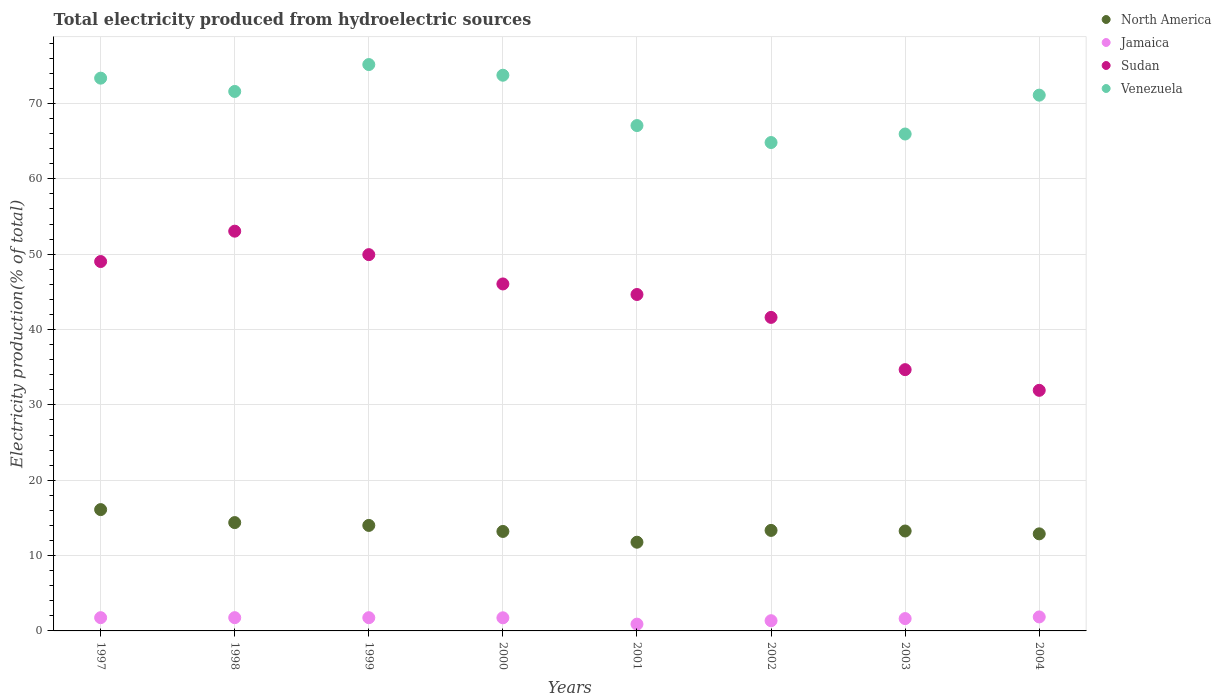Is the number of dotlines equal to the number of legend labels?
Ensure brevity in your answer.  Yes. What is the total electricity produced in Sudan in 1997?
Offer a terse response. 49.02. Across all years, what is the maximum total electricity produced in Sudan?
Offer a terse response. 53.05. Across all years, what is the minimum total electricity produced in Venezuela?
Your answer should be very brief. 64.82. In which year was the total electricity produced in Jamaica maximum?
Make the answer very short. 2004. What is the total total electricity produced in North America in the graph?
Offer a terse response. 108.94. What is the difference between the total electricity produced in North America in 1997 and that in 2004?
Give a very brief answer. 3.22. What is the difference between the total electricity produced in Venezuela in 2004 and the total electricity produced in North America in 1999?
Your response must be concise. 57.1. What is the average total electricity produced in Sudan per year?
Provide a succinct answer. 43.87. In the year 1997, what is the difference between the total electricity produced in North America and total electricity produced in Venezuela?
Your answer should be compact. -57.26. What is the ratio of the total electricity produced in Venezuela in 2000 to that in 2001?
Your answer should be very brief. 1.1. Is the difference between the total electricity produced in North America in 2003 and 2004 greater than the difference between the total electricity produced in Venezuela in 2003 and 2004?
Your response must be concise. Yes. What is the difference between the highest and the second highest total electricity produced in Venezuela?
Offer a terse response. 1.42. What is the difference between the highest and the lowest total electricity produced in Jamaica?
Offer a terse response. 0.96. Is it the case that in every year, the sum of the total electricity produced in Sudan and total electricity produced in Jamaica  is greater than the sum of total electricity produced in North America and total electricity produced in Venezuela?
Give a very brief answer. No. Is it the case that in every year, the sum of the total electricity produced in Jamaica and total electricity produced in Sudan  is greater than the total electricity produced in North America?
Provide a succinct answer. Yes. Does the total electricity produced in Jamaica monotonically increase over the years?
Provide a succinct answer. No. Is the total electricity produced in Jamaica strictly less than the total electricity produced in Venezuela over the years?
Provide a short and direct response. Yes. Are the values on the major ticks of Y-axis written in scientific E-notation?
Make the answer very short. No. Does the graph contain grids?
Provide a short and direct response. Yes. Where does the legend appear in the graph?
Keep it short and to the point. Top right. What is the title of the graph?
Your answer should be compact. Total electricity produced from hydroelectric sources. What is the label or title of the X-axis?
Give a very brief answer. Years. What is the Electricity production(% of total) in North America in 1997?
Make the answer very short. 16.1. What is the Electricity production(% of total) in Jamaica in 1997?
Ensure brevity in your answer.  1.76. What is the Electricity production(% of total) in Sudan in 1997?
Offer a terse response. 49.02. What is the Electricity production(% of total) in Venezuela in 1997?
Your response must be concise. 73.36. What is the Electricity production(% of total) of North America in 1998?
Offer a terse response. 14.38. What is the Electricity production(% of total) of Jamaica in 1998?
Keep it short and to the point. 1.76. What is the Electricity production(% of total) of Sudan in 1998?
Ensure brevity in your answer.  53.05. What is the Electricity production(% of total) in Venezuela in 1998?
Provide a succinct answer. 71.6. What is the Electricity production(% of total) of North America in 1999?
Give a very brief answer. 14. What is the Electricity production(% of total) of Jamaica in 1999?
Offer a terse response. 1.76. What is the Electricity production(% of total) of Sudan in 1999?
Make the answer very short. 49.94. What is the Electricity production(% of total) of Venezuela in 1999?
Keep it short and to the point. 75.16. What is the Electricity production(% of total) of North America in 2000?
Offer a very short reply. 13.2. What is the Electricity production(% of total) in Jamaica in 2000?
Provide a short and direct response. 1.74. What is the Electricity production(% of total) of Sudan in 2000?
Offer a terse response. 46.05. What is the Electricity production(% of total) of Venezuela in 2000?
Offer a very short reply. 73.75. What is the Electricity production(% of total) in North America in 2001?
Keep it short and to the point. 11.77. What is the Electricity production(% of total) in Jamaica in 2001?
Provide a succinct answer. 0.9. What is the Electricity production(% of total) of Sudan in 2001?
Offer a terse response. 44.65. What is the Electricity production(% of total) in Venezuela in 2001?
Your answer should be very brief. 67.07. What is the Electricity production(% of total) of North America in 2002?
Give a very brief answer. 13.34. What is the Electricity production(% of total) of Jamaica in 2002?
Your answer should be very brief. 1.36. What is the Electricity production(% of total) in Sudan in 2002?
Keep it short and to the point. 41.61. What is the Electricity production(% of total) in Venezuela in 2002?
Ensure brevity in your answer.  64.82. What is the Electricity production(% of total) in North America in 2003?
Provide a short and direct response. 13.26. What is the Electricity production(% of total) of Jamaica in 2003?
Make the answer very short. 1.64. What is the Electricity production(% of total) in Sudan in 2003?
Provide a succinct answer. 34.68. What is the Electricity production(% of total) in Venezuela in 2003?
Provide a short and direct response. 65.95. What is the Electricity production(% of total) in North America in 2004?
Your answer should be very brief. 12.88. What is the Electricity production(% of total) of Jamaica in 2004?
Make the answer very short. 1.86. What is the Electricity production(% of total) in Sudan in 2004?
Offer a very short reply. 31.93. What is the Electricity production(% of total) in Venezuela in 2004?
Your response must be concise. 71.1. Across all years, what is the maximum Electricity production(% of total) of North America?
Provide a short and direct response. 16.1. Across all years, what is the maximum Electricity production(% of total) of Jamaica?
Make the answer very short. 1.86. Across all years, what is the maximum Electricity production(% of total) in Sudan?
Provide a short and direct response. 53.05. Across all years, what is the maximum Electricity production(% of total) in Venezuela?
Ensure brevity in your answer.  75.16. Across all years, what is the minimum Electricity production(% of total) of North America?
Give a very brief answer. 11.77. Across all years, what is the minimum Electricity production(% of total) in Jamaica?
Provide a succinct answer. 0.9. Across all years, what is the minimum Electricity production(% of total) in Sudan?
Your answer should be compact. 31.93. Across all years, what is the minimum Electricity production(% of total) in Venezuela?
Offer a very short reply. 64.82. What is the total Electricity production(% of total) in North America in the graph?
Provide a succinct answer. 108.94. What is the total Electricity production(% of total) in Jamaica in the graph?
Give a very brief answer. 12.77. What is the total Electricity production(% of total) of Sudan in the graph?
Your response must be concise. 350.92. What is the total Electricity production(% of total) in Venezuela in the graph?
Keep it short and to the point. 562.8. What is the difference between the Electricity production(% of total) in North America in 1997 and that in 1998?
Your answer should be very brief. 1.72. What is the difference between the Electricity production(% of total) in Jamaica in 1997 and that in 1998?
Ensure brevity in your answer.  -0. What is the difference between the Electricity production(% of total) in Sudan in 1997 and that in 1998?
Give a very brief answer. -4.03. What is the difference between the Electricity production(% of total) of Venezuela in 1997 and that in 1998?
Offer a very short reply. 1.76. What is the difference between the Electricity production(% of total) in North America in 1997 and that in 1999?
Keep it short and to the point. 2.1. What is the difference between the Electricity production(% of total) of Jamaica in 1997 and that in 1999?
Offer a terse response. 0. What is the difference between the Electricity production(% of total) of Sudan in 1997 and that in 1999?
Provide a succinct answer. -0.91. What is the difference between the Electricity production(% of total) of Venezuela in 1997 and that in 1999?
Offer a terse response. -1.81. What is the difference between the Electricity production(% of total) in North America in 1997 and that in 2000?
Your answer should be very brief. 2.9. What is the difference between the Electricity production(% of total) in Jamaica in 1997 and that in 2000?
Provide a succinct answer. 0.02. What is the difference between the Electricity production(% of total) of Sudan in 1997 and that in 2000?
Make the answer very short. 2.97. What is the difference between the Electricity production(% of total) in Venezuela in 1997 and that in 2000?
Make the answer very short. -0.39. What is the difference between the Electricity production(% of total) of North America in 1997 and that in 2001?
Provide a short and direct response. 4.33. What is the difference between the Electricity production(% of total) in Jamaica in 1997 and that in 2001?
Keep it short and to the point. 0.86. What is the difference between the Electricity production(% of total) in Sudan in 1997 and that in 2001?
Give a very brief answer. 4.38. What is the difference between the Electricity production(% of total) of Venezuela in 1997 and that in 2001?
Give a very brief answer. 6.29. What is the difference between the Electricity production(% of total) of North America in 1997 and that in 2002?
Offer a very short reply. 2.76. What is the difference between the Electricity production(% of total) in Jamaica in 1997 and that in 2002?
Provide a short and direct response. 0.4. What is the difference between the Electricity production(% of total) in Sudan in 1997 and that in 2002?
Give a very brief answer. 7.41. What is the difference between the Electricity production(% of total) in Venezuela in 1997 and that in 2002?
Your response must be concise. 8.54. What is the difference between the Electricity production(% of total) of North America in 1997 and that in 2003?
Ensure brevity in your answer.  2.84. What is the difference between the Electricity production(% of total) of Jamaica in 1997 and that in 2003?
Give a very brief answer. 0.12. What is the difference between the Electricity production(% of total) of Sudan in 1997 and that in 2003?
Your response must be concise. 14.35. What is the difference between the Electricity production(% of total) of Venezuela in 1997 and that in 2003?
Make the answer very short. 7.41. What is the difference between the Electricity production(% of total) in North America in 1997 and that in 2004?
Provide a succinct answer. 3.22. What is the difference between the Electricity production(% of total) of Jamaica in 1997 and that in 2004?
Your response must be concise. -0.1. What is the difference between the Electricity production(% of total) of Sudan in 1997 and that in 2004?
Keep it short and to the point. 17.09. What is the difference between the Electricity production(% of total) of Venezuela in 1997 and that in 2004?
Your answer should be very brief. 2.25. What is the difference between the Electricity production(% of total) of North America in 1998 and that in 1999?
Keep it short and to the point. 0.38. What is the difference between the Electricity production(% of total) in Jamaica in 1998 and that in 1999?
Offer a very short reply. 0. What is the difference between the Electricity production(% of total) in Sudan in 1998 and that in 1999?
Ensure brevity in your answer.  3.11. What is the difference between the Electricity production(% of total) in Venezuela in 1998 and that in 1999?
Your answer should be compact. -3.57. What is the difference between the Electricity production(% of total) of North America in 1998 and that in 2000?
Keep it short and to the point. 1.17. What is the difference between the Electricity production(% of total) in Jamaica in 1998 and that in 2000?
Your response must be concise. 0.02. What is the difference between the Electricity production(% of total) in Sudan in 1998 and that in 2000?
Provide a short and direct response. 7. What is the difference between the Electricity production(% of total) in Venezuela in 1998 and that in 2000?
Provide a succinct answer. -2.15. What is the difference between the Electricity production(% of total) of North America in 1998 and that in 2001?
Give a very brief answer. 2.6. What is the difference between the Electricity production(% of total) in Jamaica in 1998 and that in 2001?
Make the answer very short. 0.86. What is the difference between the Electricity production(% of total) in Sudan in 1998 and that in 2001?
Offer a very short reply. 8.4. What is the difference between the Electricity production(% of total) in Venezuela in 1998 and that in 2001?
Your response must be concise. 4.53. What is the difference between the Electricity production(% of total) in North America in 1998 and that in 2002?
Provide a succinct answer. 1.04. What is the difference between the Electricity production(% of total) in Jamaica in 1998 and that in 2002?
Give a very brief answer. 0.4. What is the difference between the Electricity production(% of total) in Sudan in 1998 and that in 2002?
Make the answer very short. 11.44. What is the difference between the Electricity production(% of total) of Venezuela in 1998 and that in 2002?
Offer a very short reply. 6.78. What is the difference between the Electricity production(% of total) in North America in 1998 and that in 2003?
Make the answer very short. 1.12. What is the difference between the Electricity production(% of total) of Jamaica in 1998 and that in 2003?
Your response must be concise. 0.12. What is the difference between the Electricity production(% of total) in Sudan in 1998 and that in 2003?
Ensure brevity in your answer.  18.38. What is the difference between the Electricity production(% of total) in Venezuela in 1998 and that in 2003?
Provide a short and direct response. 5.65. What is the difference between the Electricity production(% of total) in North America in 1998 and that in 2004?
Your answer should be compact. 1.49. What is the difference between the Electricity production(% of total) in Jamaica in 1998 and that in 2004?
Your answer should be compact. -0.1. What is the difference between the Electricity production(% of total) in Sudan in 1998 and that in 2004?
Your answer should be compact. 21.12. What is the difference between the Electricity production(% of total) in Venezuela in 1998 and that in 2004?
Your answer should be compact. 0.49. What is the difference between the Electricity production(% of total) in North America in 1999 and that in 2000?
Ensure brevity in your answer.  0.8. What is the difference between the Electricity production(% of total) of Jamaica in 1999 and that in 2000?
Make the answer very short. 0.01. What is the difference between the Electricity production(% of total) in Sudan in 1999 and that in 2000?
Your answer should be very brief. 3.89. What is the difference between the Electricity production(% of total) in Venezuela in 1999 and that in 2000?
Offer a very short reply. 1.42. What is the difference between the Electricity production(% of total) in North America in 1999 and that in 2001?
Your response must be concise. 2.23. What is the difference between the Electricity production(% of total) in Jamaica in 1999 and that in 2001?
Provide a short and direct response. 0.85. What is the difference between the Electricity production(% of total) of Sudan in 1999 and that in 2001?
Make the answer very short. 5.29. What is the difference between the Electricity production(% of total) of Venezuela in 1999 and that in 2001?
Provide a short and direct response. 8.1. What is the difference between the Electricity production(% of total) in North America in 1999 and that in 2002?
Provide a succinct answer. 0.66. What is the difference between the Electricity production(% of total) of Jamaica in 1999 and that in 2002?
Make the answer very short. 0.4. What is the difference between the Electricity production(% of total) of Sudan in 1999 and that in 2002?
Ensure brevity in your answer.  8.33. What is the difference between the Electricity production(% of total) in Venezuela in 1999 and that in 2002?
Give a very brief answer. 10.35. What is the difference between the Electricity production(% of total) in North America in 1999 and that in 2003?
Your answer should be very brief. 0.74. What is the difference between the Electricity production(% of total) in Jamaica in 1999 and that in 2003?
Keep it short and to the point. 0.12. What is the difference between the Electricity production(% of total) of Sudan in 1999 and that in 2003?
Provide a succinct answer. 15.26. What is the difference between the Electricity production(% of total) of Venezuela in 1999 and that in 2003?
Give a very brief answer. 9.22. What is the difference between the Electricity production(% of total) in North America in 1999 and that in 2004?
Ensure brevity in your answer.  1.12. What is the difference between the Electricity production(% of total) in Jamaica in 1999 and that in 2004?
Provide a short and direct response. -0.1. What is the difference between the Electricity production(% of total) in Sudan in 1999 and that in 2004?
Your answer should be very brief. 18.01. What is the difference between the Electricity production(% of total) in Venezuela in 1999 and that in 2004?
Provide a succinct answer. 4.06. What is the difference between the Electricity production(% of total) of North America in 2000 and that in 2001?
Provide a short and direct response. 1.43. What is the difference between the Electricity production(% of total) in Jamaica in 2000 and that in 2001?
Your answer should be compact. 0.84. What is the difference between the Electricity production(% of total) of Sudan in 2000 and that in 2001?
Your response must be concise. 1.4. What is the difference between the Electricity production(% of total) of Venezuela in 2000 and that in 2001?
Provide a short and direct response. 6.68. What is the difference between the Electricity production(% of total) of North America in 2000 and that in 2002?
Make the answer very short. -0.14. What is the difference between the Electricity production(% of total) of Jamaica in 2000 and that in 2002?
Keep it short and to the point. 0.39. What is the difference between the Electricity production(% of total) of Sudan in 2000 and that in 2002?
Your answer should be very brief. 4.44. What is the difference between the Electricity production(% of total) of Venezuela in 2000 and that in 2002?
Your answer should be very brief. 8.93. What is the difference between the Electricity production(% of total) of North America in 2000 and that in 2003?
Offer a terse response. -0.06. What is the difference between the Electricity production(% of total) in Jamaica in 2000 and that in 2003?
Give a very brief answer. 0.1. What is the difference between the Electricity production(% of total) in Sudan in 2000 and that in 2003?
Provide a short and direct response. 11.37. What is the difference between the Electricity production(% of total) in Venezuela in 2000 and that in 2003?
Your answer should be very brief. 7.8. What is the difference between the Electricity production(% of total) in North America in 2000 and that in 2004?
Your response must be concise. 0.32. What is the difference between the Electricity production(% of total) in Jamaica in 2000 and that in 2004?
Provide a short and direct response. -0.12. What is the difference between the Electricity production(% of total) of Sudan in 2000 and that in 2004?
Provide a short and direct response. 14.12. What is the difference between the Electricity production(% of total) in Venezuela in 2000 and that in 2004?
Make the answer very short. 2.64. What is the difference between the Electricity production(% of total) of North America in 2001 and that in 2002?
Ensure brevity in your answer.  -1.57. What is the difference between the Electricity production(% of total) of Jamaica in 2001 and that in 2002?
Give a very brief answer. -0.45. What is the difference between the Electricity production(% of total) in Sudan in 2001 and that in 2002?
Give a very brief answer. 3.04. What is the difference between the Electricity production(% of total) of Venezuela in 2001 and that in 2002?
Your answer should be very brief. 2.25. What is the difference between the Electricity production(% of total) of North America in 2001 and that in 2003?
Your answer should be very brief. -1.49. What is the difference between the Electricity production(% of total) in Jamaica in 2001 and that in 2003?
Give a very brief answer. -0.74. What is the difference between the Electricity production(% of total) of Sudan in 2001 and that in 2003?
Give a very brief answer. 9.97. What is the difference between the Electricity production(% of total) of Venezuela in 2001 and that in 2003?
Your answer should be very brief. 1.12. What is the difference between the Electricity production(% of total) of North America in 2001 and that in 2004?
Give a very brief answer. -1.11. What is the difference between the Electricity production(% of total) in Jamaica in 2001 and that in 2004?
Offer a terse response. -0.96. What is the difference between the Electricity production(% of total) in Sudan in 2001 and that in 2004?
Ensure brevity in your answer.  12.72. What is the difference between the Electricity production(% of total) of Venezuela in 2001 and that in 2004?
Keep it short and to the point. -4.04. What is the difference between the Electricity production(% of total) in North America in 2002 and that in 2003?
Your answer should be very brief. 0.08. What is the difference between the Electricity production(% of total) in Jamaica in 2002 and that in 2003?
Make the answer very short. -0.28. What is the difference between the Electricity production(% of total) in Sudan in 2002 and that in 2003?
Offer a terse response. 6.94. What is the difference between the Electricity production(% of total) in Venezuela in 2002 and that in 2003?
Your answer should be very brief. -1.13. What is the difference between the Electricity production(% of total) in North America in 2002 and that in 2004?
Give a very brief answer. 0.46. What is the difference between the Electricity production(% of total) in Jamaica in 2002 and that in 2004?
Your response must be concise. -0.5. What is the difference between the Electricity production(% of total) in Sudan in 2002 and that in 2004?
Offer a terse response. 9.68. What is the difference between the Electricity production(% of total) in Venezuela in 2002 and that in 2004?
Keep it short and to the point. -6.29. What is the difference between the Electricity production(% of total) in North America in 2003 and that in 2004?
Keep it short and to the point. 0.38. What is the difference between the Electricity production(% of total) in Jamaica in 2003 and that in 2004?
Provide a succinct answer. -0.22. What is the difference between the Electricity production(% of total) in Sudan in 2003 and that in 2004?
Give a very brief answer. 2.75. What is the difference between the Electricity production(% of total) in Venezuela in 2003 and that in 2004?
Offer a very short reply. -5.16. What is the difference between the Electricity production(% of total) in North America in 1997 and the Electricity production(% of total) in Jamaica in 1998?
Offer a terse response. 14.34. What is the difference between the Electricity production(% of total) of North America in 1997 and the Electricity production(% of total) of Sudan in 1998?
Give a very brief answer. -36.95. What is the difference between the Electricity production(% of total) of North America in 1997 and the Electricity production(% of total) of Venezuela in 1998?
Provide a short and direct response. -55.5. What is the difference between the Electricity production(% of total) of Jamaica in 1997 and the Electricity production(% of total) of Sudan in 1998?
Provide a short and direct response. -51.29. What is the difference between the Electricity production(% of total) of Jamaica in 1997 and the Electricity production(% of total) of Venezuela in 1998?
Keep it short and to the point. -69.84. What is the difference between the Electricity production(% of total) of Sudan in 1997 and the Electricity production(% of total) of Venezuela in 1998?
Make the answer very short. -22.57. What is the difference between the Electricity production(% of total) in North America in 1997 and the Electricity production(% of total) in Jamaica in 1999?
Offer a very short reply. 14.35. What is the difference between the Electricity production(% of total) in North America in 1997 and the Electricity production(% of total) in Sudan in 1999?
Give a very brief answer. -33.84. What is the difference between the Electricity production(% of total) of North America in 1997 and the Electricity production(% of total) of Venezuela in 1999?
Ensure brevity in your answer.  -59.06. What is the difference between the Electricity production(% of total) of Jamaica in 1997 and the Electricity production(% of total) of Sudan in 1999?
Offer a very short reply. -48.18. What is the difference between the Electricity production(% of total) in Jamaica in 1997 and the Electricity production(% of total) in Venezuela in 1999?
Offer a terse response. -73.41. What is the difference between the Electricity production(% of total) in Sudan in 1997 and the Electricity production(% of total) in Venezuela in 1999?
Make the answer very short. -26.14. What is the difference between the Electricity production(% of total) of North America in 1997 and the Electricity production(% of total) of Jamaica in 2000?
Provide a succinct answer. 14.36. What is the difference between the Electricity production(% of total) in North America in 1997 and the Electricity production(% of total) in Sudan in 2000?
Your answer should be very brief. -29.95. What is the difference between the Electricity production(% of total) of North America in 1997 and the Electricity production(% of total) of Venezuela in 2000?
Your answer should be compact. -57.65. What is the difference between the Electricity production(% of total) in Jamaica in 1997 and the Electricity production(% of total) in Sudan in 2000?
Offer a terse response. -44.29. What is the difference between the Electricity production(% of total) of Jamaica in 1997 and the Electricity production(% of total) of Venezuela in 2000?
Keep it short and to the point. -71.99. What is the difference between the Electricity production(% of total) in Sudan in 1997 and the Electricity production(% of total) in Venezuela in 2000?
Keep it short and to the point. -24.73. What is the difference between the Electricity production(% of total) of North America in 1997 and the Electricity production(% of total) of Jamaica in 2001?
Your answer should be very brief. 15.2. What is the difference between the Electricity production(% of total) of North America in 1997 and the Electricity production(% of total) of Sudan in 2001?
Your answer should be very brief. -28.55. What is the difference between the Electricity production(% of total) of North America in 1997 and the Electricity production(% of total) of Venezuela in 2001?
Provide a short and direct response. -50.97. What is the difference between the Electricity production(% of total) in Jamaica in 1997 and the Electricity production(% of total) in Sudan in 2001?
Keep it short and to the point. -42.89. What is the difference between the Electricity production(% of total) of Jamaica in 1997 and the Electricity production(% of total) of Venezuela in 2001?
Provide a succinct answer. -65.31. What is the difference between the Electricity production(% of total) in Sudan in 1997 and the Electricity production(% of total) in Venezuela in 2001?
Make the answer very short. -18.04. What is the difference between the Electricity production(% of total) in North America in 1997 and the Electricity production(% of total) in Jamaica in 2002?
Give a very brief answer. 14.74. What is the difference between the Electricity production(% of total) in North America in 1997 and the Electricity production(% of total) in Sudan in 2002?
Your answer should be compact. -25.51. What is the difference between the Electricity production(% of total) of North America in 1997 and the Electricity production(% of total) of Venezuela in 2002?
Your answer should be very brief. -48.71. What is the difference between the Electricity production(% of total) of Jamaica in 1997 and the Electricity production(% of total) of Sudan in 2002?
Your answer should be compact. -39.85. What is the difference between the Electricity production(% of total) in Jamaica in 1997 and the Electricity production(% of total) in Venezuela in 2002?
Offer a very short reply. -63.06. What is the difference between the Electricity production(% of total) of Sudan in 1997 and the Electricity production(% of total) of Venezuela in 2002?
Give a very brief answer. -15.79. What is the difference between the Electricity production(% of total) in North America in 1997 and the Electricity production(% of total) in Jamaica in 2003?
Your response must be concise. 14.46. What is the difference between the Electricity production(% of total) of North America in 1997 and the Electricity production(% of total) of Sudan in 2003?
Offer a very short reply. -18.57. What is the difference between the Electricity production(% of total) of North America in 1997 and the Electricity production(% of total) of Venezuela in 2003?
Provide a succinct answer. -49.85. What is the difference between the Electricity production(% of total) of Jamaica in 1997 and the Electricity production(% of total) of Sudan in 2003?
Ensure brevity in your answer.  -32.92. What is the difference between the Electricity production(% of total) of Jamaica in 1997 and the Electricity production(% of total) of Venezuela in 2003?
Give a very brief answer. -64.19. What is the difference between the Electricity production(% of total) of Sudan in 1997 and the Electricity production(% of total) of Venezuela in 2003?
Make the answer very short. -16.92. What is the difference between the Electricity production(% of total) of North America in 1997 and the Electricity production(% of total) of Jamaica in 2004?
Provide a succinct answer. 14.24. What is the difference between the Electricity production(% of total) in North America in 1997 and the Electricity production(% of total) in Sudan in 2004?
Keep it short and to the point. -15.83. What is the difference between the Electricity production(% of total) in North America in 1997 and the Electricity production(% of total) in Venezuela in 2004?
Offer a terse response. -55. What is the difference between the Electricity production(% of total) of Jamaica in 1997 and the Electricity production(% of total) of Sudan in 2004?
Your response must be concise. -30.17. What is the difference between the Electricity production(% of total) of Jamaica in 1997 and the Electricity production(% of total) of Venezuela in 2004?
Offer a very short reply. -69.35. What is the difference between the Electricity production(% of total) of Sudan in 1997 and the Electricity production(% of total) of Venezuela in 2004?
Your response must be concise. -22.08. What is the difference between the Electricity production(% of total) in North America in 1998 and the Electricity production(% of total) in Jamaica in 1999?
Provide a short and direct response. 12.62. What is the difference between the Electricity production(% of total) in North America in 1998 and the Electricity production(% of total) in Sudan in 1999?
Your response must be concise. -35.56. What is the difference between the Electricity production(% of total) in North America in 1998 and the Electricity production(% of total) in Venezuela in 1999?
Offer a very short reply. -60.79. What is the difference between the Electricity production(% of total) of Jamaica in 1998 and the Electricity production(% of total) of Sudan in 1999?
Offer a very short reply. -48.18. What is the difference between the Electricity production(% of total) in Jamaica in 1998 and the Electricity production(% of total) in Venezuela in 1999?
Offer a terse response. -73.41. What is the difference between the Electricity production(% of total) in Sudan in 1998 and the Electricity production(% of total) in Venezuela in 1999?
Offer a terse response. -22.11. What is the difference between the Electricity production(% of total) in North America in 1998 and the Electricity production(% of total) in Jamaica in 2000?
Keep it short and to the point. 12.64. What is the difference between the Electricity production(% of total) of North America in 1998 and the Electricity production(% of total) of Sudan in 2000?
Offer a terse response. -31.67. What is the difference between the Electricity production(% of total) in North America in 1998 and the Electricity production(% of total) in Venezuela in 2000?
Your response must be concise. -59.37. What is the difference between the Electricity production(% of total) of Jamaica in 1998 and the Electricity production(% of total) of Sudan in 2000?
Provide a succinct answer. -44.29. What is the difference between the Electricity production(% of total) of Jamaica in 1998 and the Electricity production(% of total) of Venezuela in 2000?
Ensure brevity in your answer.  -71.99. What is the difference between the Electricity production(% of total) in Sudan in 1998 and the Electricity production(% of total) in Venezuela in 2000?
Ensure brevity in your answer.  -20.7. What is the difference between the Electricity production(% of total) of North America in 1998 and the Electricity production(% of total) of Jamaica in 2001?
Your response must be concise. 13.48. What is the difference between the Electricity production(% of total) of North America in 1998 and the Electricity production(% of total) of Sudan in 2001?
Offer a very short reply. -30.27. What is the difference between the Electricity production(% of total) in North America in 1998 and the Electricity production(% of total) in Venezuela in 2001?
Give a very brief answer. -52.69. What is the difference between the Electricity production(% of total) of Jamaica in 1998 and the Electricity production(% of total) of Sudan in 2001?
Offer a very short reply. -42.89. What is the difference between the Electricity production(% of total) of Jamaica in 1998 and the Electricity production(% of total) of Venezuela in 2001?
Make the answer very short. -65.31. What is the difference between the Electricity production(% of total) of Sudan in 1998 and the Electricity production(% of total) of Venezuela in 2001?
Ensure brevity in your answer.  -14.02. What is the difference between the Electricity production(% of total) of North America in 1998 and the Electricity production(% of total) of Jamaica in 2002?
Offer a terse response. 13.02. What is the difference between the Electricity production(% of total) of North America in 1998 and the Electricity production(% of total) of Sudan in 2002?
Keep it short and to the point. -27.23. What is the difference between the Electricity production(% of total) of North America in 1998 and the Electricity production(% of total) of Venezuela in 2002?
Ensure brevity in your answer.  -50.44. What is the difference between the Electricity production(% of total) in Jamaica in 1998 and the Electricity production(% of total) in Sudan in 2002?
Your answer should be compact. -39.85. What is the difference between the Electricity production(% of total) in Jamaica in 1998 and the Electricity production(% of total) in Venezuela in 2002?
Make the answer very short. -63.06. What is the difference between the Electricity production(% of total) of Sudan in 1998 and the Electricity production(% of total) of Venezuela in 2002?
Offer a very short reply. -11.76. What is the difference between the Electricity production(% of total) of North America in 1998 and the Electricity production(% of total) of Jamaica in 2003?
Your answer should be very brief. 12.74. What is the difference between the Electricity production(% of total) in North America in 1998 and the Electricity production(% of total) in Sudan in 2003?
Provide a succinct answer. -20.3. What is the difference between the Electricity production(% of total) of North America in 1998 and the Electricity production(% of total) of Venezuela in 2003?
Your response must be concise. -51.57. What is the difference between the Electricity production(% of total) of Jamaica in 1998 and the Electricity production(% of total) of Sudan in 2003?
Give a very brief answer. -32.92. What is the difference between the Electricity production(% of total) of Jamaica in 1998 and the Electricity production(% of total) of Venezuela in 2003?
Your answer should be compact. -64.19. What is the difference between the Electricity production(% of total) in Sudan in 1998 and the Electricity production(% of total) in Venezuela in 2003?
Your answer should be very brief. -12.89. What is the difference between the Electricity production(% of total) in North America in 1998 and the Electricity production(% of total) in Jamaica in 2004?
Your response must be concise. 12.52. What is the difference between the Electricity production(% of total) of North America in 1998 and the Electricity production(% of total) of Sudan in 2004?
Offer a very short reply. -17.55. What is the difference between the Electricity production(% of total) in North America in 1998 and the Electricity production(% of total) in Venezuela in 2004?
Offer a terse response. -56.73. What is the difference between the Electricity production(% of total) in Jamaica in 1998 and the Electricity production(% of total) in Sudan in 2004?
Your answer should be very brief. -30.17. What is the difference between the Electricity production(% of total) of Jamaica in 1998 and the Electricity production(% of total) of Venezuela in 2004?
Ensure brevity in your answer.  -69.35. What is the difference between the Electricity production(% of total) in Sudan in 1998 and the Electricity production(% of total) in Venezuela in 2004?
Offer a terse response. -18.05. What is the difference between the Electricity production(% of total) of North America in 1999 and the Electricity production(% of total) of Jamaica in 2000?
Ensure brevity in your answer.  12.26. What is the difference between the Electricity production(% of total) of North America in 1999 and the Electricity production(% of total) of Sudan in 2000?
Provide a succinct answer. -32.05. What is the difference between the Electricity production(% of total) in North America in 1999 and the Electricity production(% of total) in Venezuela in 2000?
Make the answer very short. -59.75. What is the difference between the Electricity production(% of total) in Jamaica in 1999 and the Electricity production(% of total) in Sudan in 2000?
Offer a very short reply. -44.29. What is the difference between the Electricity production(% of total) of Jamaica in 1999 and the Electricity production(% of total) of Venezuela in 2000?
Your response must be concise. -71.99. What is the difference between the Electricity production(% of total) in Sudan in 1999 and the Electricity production(% of total) in Venezuela in 2000?
Provide a succinct answer. -23.81. What is the difference between the Electricity production(% of total) of North America in 1999 and the Electricity production(% of total) of Jamaica in 2001?
Provide a succinct answer. 13.1. What is the difference between the Electricity production(% of total) of North America in 1999 and the Electricity production(% of total) of Sudan in 2001?
Your answer should be very brief. -30.65. What is the difference between the Electricity production(% of total) in North America in 1999 and the Electricity production(% of total) in Venezuela in 2001?
Provide a succinct answer. -53.07. What is the difference between the Electricity production(% of total) in Jamaica in 1999 and the Electricity production(% of total) in Sudan in 2001?
Offer a very short reply. -42.89. What is the difference between the Electricity production(% of total) of Jamaica in 1999 and the Electricity production(% of total) of Venezuela in 2001?
Make the answer very short. -65.31. What is the difference between the Electricity production(% of total) in Sudan in 1999 and the Electricity production(% of total) in Venezuela in 2001?
Provide a short and direct response. -17.13. What is the difference between the Electricity production(% of total) of North America in 1999 and the Electricity production(% of total) of Jamaica in 2002?
Your answer should be compact. 12.65. What is the difference between the Electricity production(% of total) in North America in 1999 and the Electricity production(% of total) in Sudan in 2002?
Ensure brevity in your answer.  -27.61. What is the difference between the Electricity production(% of total) in North America in 1999 and the Electricity production(% of total) in Venezuela in 2002?
Offer a terse response. -50.81. What is the difference between the Electricity production(% of total) in Jamaica in 1999 and the Electricity production(% of total) in Sudan in 2002?
Give a very brief answer. -39.85. What is the difference between the Electricity production(% of total) in Jamaica in 1999 and the Electricity production(% of total) in Venezuela in 2002?
Your response must be concise. -63.06. What is the difference between the Electricity production(% of total) of Sudan in 1999 and the Electricity production(% of total) of Venezuela in 2002?
Make the answer very short. -14.88. What is the difference between the Electricity production(% of total) in North America in 1999 and the Electricity production(% of total) in Jamaica in 2003?
Ensure brevity in your answer.  12.36. What is the difference between the Electricity production(% of total) in North America in 1999 and the Electricity production(% of total) in Sudan in 2003?
Your response must be concise. -20.67. What is the difference between the Electricity production(% of total) in North America in 1999 and the Electricity production(% of total) in Venezuela in 2003?
Offer a terse response. -51.95. What is the difference between the Electricity production(% of total) of Jamaica in 1999 and the Electricity production(% of total) of Sudan in 2003?
Keep it short and to the point. -32.92. What is the difference between the Electricity production(% of total) of Jamaica in 1999 and the Electricity production(% of total) of Venezuela in 2003?
Give a very brief answer. -64.19. What is the difference between the Electricity production(% of total) in Sudan in 1999 and the Electricity production(% of total) in Venezuela in 2003?
Provide a succinct answer. -16.01. What is the difference between the Electricity production(% of total) in North America in 1999 and the Electricity production(% of total) in Jamaica in 2004?
Make the answer very short. 12.14. What is the difference between the Electricity production(% of total) of North America in 1999 and the Electricity production(% of total) of Sudan in 2004?
Ensure brevity in your answer.  -17.93. What is the difference between the Electricity production(% of total) in North America in 1999 and the Electricity production(% of total) in Venezuela in 2004?
Make the answer very short. -57.1. What is the difference between the Electricity production(% of total) of Jamaica in 1999 and the Electricity production(% of total) of Sudan in 2004?
Your answer should be very brief. -30.17. What is the difference between the Electricity production(% of total) of Jamaica in 1999 and the Electricity production(% of total) of Venezuela in 2004?
Your answer should be compact. -69.35. What is the difference between the Electricity production(% of total) in Sudan in 1999 and the Electricity production(% of total) in Venezuela in 2004?
Your answer should be compact. -21.17. What is the difference between the Electricity production(% of total) in North America in 2000 and the Electricity production(% of total) in Jamaica in 2001?
Offer a terse response. 12.3. What is the difference between the Electricity production(% of total) of North America in 2000 and the Electricity production(% of total) of Sudan in 2001?
Your answer should be compact. -31.45. What is the difference between the Electricity production(% of total) of North America in 2000 and the Electricity production(% of total) of Venezuela in 2001?
Make the answer very short. -53.87. What is the difference between the Electricity production(% of total) in Jamaica in 2000 and the Electricity production(% of total) in Sudan in 2001?
Offer a very short reply. -42.91. What is the difference between the Electricity production(% of total) of Jamaica in 2000 and the Electricity production(% of total) of Venezuela in 2001?
Your answer should be very brief. -65.33. What is the difference between the Electricity production(% of total) of Sudan in 2000 and the Electricity production(% of total) of Venezuela in 2001?
Offer a terse response. -21.02. What is the difference between the Electricity production(% of total) of North America in 2000 and the Electricity production(% of total) of Jamaica in 2002?
Ensure brevity in your answer.  11.85. What is the difference between the Electricity production(% of total) of North America in 2000 and the Electricity production(% of total) of Sudan in 2002?
Offer a very short reply. -28.41. What is the difference between the Electricity production(% of total) of North America in 2000 and the Electricity production(% of total) of Venezuela in 2002?
Provide a short and direct response. -51.61. What is the difference between the Electricity production(% of total) of Jamaica in 2000 and the Electricity production(% of total) of Sudan in 2002?
Make the answer very short. -39.87. What is the difference between the Electricity production(% of total) of Jamaica in 2000 and the Electricity production(% of total) of Venezuela in 2002?
Offer a very short reply. -63.07. What is the difference between the Electricity production(% of total) of Sudan in 2000 and the Electricity production(% of total) of Venezuela in 2002?
Offer a terse response. -18.77. What is the difference between the Electricity production(% of total) in North America in 2000 and the Electricity production(% of total) in Jamaica in 2003?
Provide a short and direct response. 11.56. What is the difference between the Electricity production(% of total) in North America in 2000 and the Electricity production(% of total) in Sudan in 2003?
Your response must be concise. -21.47. What is the difference between the Electricity production(% of total) in North America in 2000 and the Electricity production(% of total) in Venezuela in 2003?
Your answer should be compact. -52.74. What is the difference between the Electricity production(% of total) in Jamaica in 2000 and the Electricity production(% of total) in Sudan in 2003?
Keep it short and to the point. -32.93. What is the difference between the Electricity production(% of total) in Jamaica in 2000 and the Electricity production(% of total) in Venezuela in 2003?
Your answer should be compact. -64.21. What is the difference between the Electricity production(% of total) of Sudan in 2000 and the Electricity production(% of total) of Venezuela in 2003?
Give a very brief answer. -19.9. What is the difference between the Electricity production(% of total) of North America in 2000 and the Electricity production(% of total) of Jamaica in 2004?
Ensure brevity in your answer.  11.35. What is the difference between the Electricity production(% of total) in North America in 2000 and the Electricity production(% of total) in Sudan in 2004?
Provide a succinct answer. -18.73. What is the difference between the Electricity production(% of total) in North America in 2000 and the Electricity production(% of total) in Venezuela in 2004?
Provide a short and direct response. -57.9. What is the difference between the Electricity production(% of total) of Jamaica in 2000 and the Electricity production(% of total) of Sudan in 2004?
Provide a succinct answer. -30.19. What is the difference between the Electricity production(% of total) of Jamaica in 2000 and the Electricity production(% of total) of Venezuela in 2004?
Offer a very short reply. -69.36. What is the difference between the Electricity production(% of total) in Sudan in 2000 and the Electricity production(% of total) in Venezuela in 2004?
Ensure brevity in your answer.  -25.06. What is the difference between the Electricity production(% of total) of North America in 2001 and the Electricity production(% of total) of Jamaica in 2002?
Your response must be concise. 10.42. What is the difference between the Electricity production(% of total) of North America in 2001 and the Electricity production(% of total) of Sudan in 2002?
Your answer should be very brief. -29.84. What is the difference between the Electricity production(% of total) of North America in 2001 and the Electricity production(% of total) of Venezuela in 2002?
Keep it short and to the point. -53.04. What is the difference between the Electricity production(% of total) of Jamaica in 2001 and the Electricity production(% of total) of Sudan in 2002?
Keep it short and to the point. -40.71. What is the difference between the Electricity production(% of total) in Jamaica in 2001 and the Electricity production(% of total) in Venezuela in 2002?
Ensure brevity in your answer.  -63.91. What is the difference between the Electricity production(% of total) in Sudan in 2001 and the Electricity production(% of total) in Venezuela in 2002?
Provide a succinct answer. -20.17. What is the difference between the Electricity production(% of total) of North America in 2001 and the Electricity production(% of total) of Jamaica in 2003?
Your response must be concise. 10.14. What is the difference between the Electricity production(% of total) of North America in 2001 and the Electricity production(% of total) of Sudan in 2003?
Your answer should be compact. -22.9. What is the difference between the Electricity production(% of total) in North America in 2001 and the Electricity production(% of total) in Venezuela in 2003?
Your response must be concise. -54.17. What is the difference between the Electricity production(% of total) of Jamaica in 2001 and the Electricity production(% of total) of Sudan in 2003?
Your response must be concise. -33.77. What is the difference between the Electricity production(% of total) of Jamaica in 2001 and the Electricity production(% of total) of Venezuela in 2003?
Your answer should be very brief. -65.04. What is the difference between the Electricity production(% of total) in Sudan in 2001 and the Electricity production(% of total) in Venezuela in 2003?
Your answer should be very brief. -21.3. What is the difference between the Electricity production(% of total) of North America in 2001 and the Electricity production(% of total) of Jamaica in 2004?
Provide a short and direct response. 9.92. What is the difference between the Electricity production(% of total) of North America in 2001 and the Electricity production(% of total) of Sudan in 2004?
Offer a terse response. -20.16. What is the difference between the Electricity production(% of total) of North America in 2001 and the Electricity production(% of total) of Venezuela in 2004?
Give a very brief answer. -59.33. What is the difference between the Electricity production(% of total) of Jamaica in 2001 and the Electricity production(% of total) of Sudan in 2004?
Give a very brief answer. -31.03. What is the difference between the Electricity production(% of total) of Jamaica in 2001 and the Electricity production(% of total) of Venezuela in 2004?
Provide a succinct answer. -70.2. What is the difference between the Electricity production(% of total) of Sudan in 2001 and the Electricity production(% of total) of Venezuela in 2004?
Keep it short and to the point. -26.46. What is the difference between the Electricity production(% of total) of North America in 2002 and the Electricity production(% of total) of Jamaica in 2003?
Provide a succinct answer. 11.7. What is the difference between the Electricity production(% of total) in North America in 2002 and the Electricity production(% of total) in Sudan in 2003?
Your answer should be very brief. -21.33. What is the difference between the Electricity production(% of total) in North America in 2002 and the Electricity production(% of total) in Venezuela in 2003?
Offer a terse response. -52.61. What is the difference between the Electricity production(% of total) of Jamaica in 2002 and the Electricity production(% of total) of Sudan in 2003?
Your response must be concise. -33.32. What is the difference between the Electricity production(% of total) of Jamaica in 2002 and the Electricity production(% of total) of Venezuela in 2003?
Offer a very short reply. -64.59. What is the difference between the Electricity production(% of total) in Sudan in 2002 and the Electricity production(% of total) in Venezuela in 2003?
Ensure brevity in your answer.  -24.34. What is the difference between the Electricity production(% of total) of North America in 2002 and the Electricity production(% of total) of Jamaica in 2004?
Ensure brevity in your answer.  11.48. What is the difference between the Electricity production(% of total) in North America in 2002 and the Electricity production(% of total) in Sudan in 2004?
Offer a very short reply. -18.59. What is the difference between the Electricity production(% of total) of North America in 2002 and the Electricity production(% of total) of Venezuela in 2004?
Ensure brevity in your answer.  -57.76. What is the difference between the Electricity production(% of total) of Jamaica in 2002 and the Electricity production(% of total) of Sudan in 2004?
Offer a very short reply. -30.57. What is the difference between the Electricity production(% of total) of Jamaica in 2002 and the Electricity production(% of total) of Venezuela in 2004?
Offer a terse response. -69.75. What is the difference between the Electricity production(% of total) of Sudan in 2002 and the Electricity production(% of total) of Venezuela in 2004?
Keep it short and to the point. -29.49. What is the difference between the Electricity production(% of total) in North America in 2003 and the Electricity production(% of total) in Jamaica in 2004?
Your answer should be compact. 11.4. What is the difference between the Electricity production(% of total) in North America in 2003 and the Electricity production(% of total) in Sudan in 2004?
Your answer should be very brief. -18.67. What is the difference between the Electricity production(% of total) in North America in 2003 and the Electricity production(% of total) in Venezuela in 2004?
Offer a terse response. -57.85. What is the difference between the Electricity production(% of total) in Jamaica in 2003 and the Electricity production(% of total) in Sudan in 2004?
Offer a very short reply. -30.29. What is the difference between the Electricity production(% of total) in Jamaica in 2003 and the Electricity production(% of total) in Venezuela in 2004?
Offer a very short reply. -69.47. What is the difference between the Electricity production(% of total) in Sudan in 2003 and the Electricity production(% of total) in Venezuela in 2004?
Keep it short and to the point. -36.43. What is the average Electricity production(% of total) of North America per year?
Your answer should be compact. 13.62. What is the average Electricity production(% of total) in Jamaica per year?
Your answer should be very brief. 1.6. What is the average Electricity production(% of total) in Sudan per year?
Give a very brief answer. 43.87. What is the average Electricity production(% of total) of Venezuela per year?
Your answer should be very brief. 70.35. In the year 1997, what is the difference between the Electricity production(% of total) in North America and Electricity production(% of total) in Jamaica?
Offer a terse response. 14.34. In the year 1997, what is the difference between the Electricity production(% of total) of North America and Electricity production(% of total) of Sudan?
Provide a short and direct response. -32.92. In the year 1997, what is the difference between the Electricity production(% of total) in North America and Electricity production(% of total) in Venezuela?
Offer a very short reply. -57.26. In the year 1997, what is the difference between the Electricity production(% of total) in Jamaica and Electricity production(% of total) in Sudan?
Keep it short and to the point. -47.26. In the year 1997, what is the difference between the Electricity production(% of total) in Jamaica and Electricity production(% of total) in Venezuela?
Your answer should be compact. -71.6. In the year 1997, what is the difference between the Electricity production(% of total) in Sudan and Electricity production(% of total) in Venezuela?
Ensure brevity in your answer.  -24.34. In the year 1998, what is the difference between the Electricity production(% of total) of North America and Electricity production(% of total) of Jamaica?
Offer a very short reply. 12.62. In the year 1998, what is the difference between the Electricity production(% of total) in North America and Electricity production(% of total) in Sudan?
Provide a short and direct response. -38.67. In the year 1998, what is the difference between the Electricity production(% of total) of North America and Electricity production(% of total) of Venezuela?
Offer a very short reply. -57.22. In the year 1998, what is the difference between the Electricity production(% of total) of Jamaica and Electricity production(% of total) of Sudan?
Offer a terse response. -51.29. In the year 1998, what is the difference between the Electricity production(% of total) in Jamaica and Electricity production(% of total) in Venezuela?
Provide a short and direct response. -69.84. In the year 1998, what is the difference between the Electricity production(% of total) in Sudan and Electricity production(% of total) in Venezuela?
Provide a short and direct response. -18.54. In the year 1999, what is the difference between the Electricity production(% of total) in North America and Electricity production(% of total) in Jamaica?
Make the answer very short. 12.25. In the year 1999, what is the difference between the Electricity production(% of total) in North America and Electricity production(% of total) in Sudan?
Ensure brevity in your answer.  -35.94. In the year 1999, what is the difference between the Electricity production(% of total) of North America and Electricity production(% of total) of Venezuela?
Offer a very short reply. -61.16. In the year 1999, what is the difference between the Electricity production(% of total) of Jamaica and Electricity production(% of total) of Sudan?
Give a very brief answer. -48.18. In the year 1999, what is the difference between the Electricity production(% of total) in Jamaica and Electricity production(% of total) in Venezuela?
Your answer should be compact. -73.41. In the year 1999, what is the difference between the Electricity production(% of total) in Sudan and Electricity production(% of total) in Venezuela?
Make the answer very short. -25.23. In the year 2000, what is the difference between the Electricity production(% of total) of North America and Electricity production(% of total) of Jamaica?
Your answer should be very brief. 11.46. In the year 2000, what is the difference between the Electricity production(% of total) of North America and Electricity production(% of total) of Sudan?
Make the answer very short. -32.85. In the year 2000, what is the difference between the Electricity production(% of total) in North America and Electricity production(% of total) in Venezuela?
Your response must be concise. -60.55. In the year 2000, what is the difference between the Electricity production(% of total) of Jamaica and Electricity production(% of total) of Sudan?
Give a very brief answer. -44.31. In the year 2000, what is the difference between the Electricity production(% of total) in Jamaica and Electricity production(% of total) in Venezuela?
Your response must be concise. -72.01. In the year 2000, what is the difference between the Electricity production(% of total) in Sudan and Electricity production(% of total) in Venezuela?
Provide a succinct answer. -27.7. In the year 2001, what is the difference between the Electricity production(% of total) of North America and Electricity production(% of total) of Jamaica?
Give a very brief answer. 10.87. In the year 2001, what is the difference between the Electricity production(% of total) in North America and Electricity production(% of total) in Sudan?
Offer a very short reply. -32.88. In the year 2001, what is the difference between the Electricity production(% of total) in North America and Electricity production(% of total) in Venezuela?
Your answer should be compact. -55.3. In the year 2001, what is the difference between the Electricity production(% of total) in Jamaica and Electricity production(% of total) in Sudan?
Keep it short and to the point. -43.75. In the year 2001, what is the difference between the Electricity production(% of total) in Jamaica and Electricity production(% of total) in Venezuela?
Make the answer very short. -66.17. In the year 2001, what is the difference between the Electricity production(% of total) in Sudan and Electricity production(% of total) in Venezuela?
Offer a terse response. -22.42. In the year 2002, what is the difference between the Electricity production(% of total) in North America and Electricity production(% of total) in Jamaica?
Provide a succinct answer. 11.98. In the year 2002, what is the difference between the Electricity production(% of total) in North America and Electricity production(% of total) in Sudan?
Your answer should be very brief. -28.27. In the year 2002, what is the difference between the Electricity production(% of total) of North America and Electricity production(% of total) of Venezuela?
Provide a succinct answer. -51.47. In the year 2002, what is the difference between the Electricity production(% of total) in Jamaica and Electricity production(% of total) in Sudan?
Provide a succinct answer. -40.25. In the year 2002, what is the difference between the Electricity production(% of total) in Jamaica and Electricity production(% of total) in Venezuela?
Offer a very short reply. -63.46. In the year 2002, what is the difference between the Electricity production(% of total) in Sudan and Electricity production(% of total) in Venezuela?
Your answer should be very brief. -23.21. In the year 2003, what is the difference between the Electricity production(% of total) of North America and Electricity production(% of total) of Jamaica?
Ensure brevity in your answer.  11.62. In the year 2003, what is the difference between the Electricity production(% of total) in North America and Electricity production(% of total) in Sudan?
Your answer should be very brief. -21.42. In the year 2003, what is the difference between the Electricity production(% of total) of North America and Electricity production(% of total) of Venezuela?
Your answer should be compact. -52.69. In the year 2003, what is the difference between the Electricity production(% of total) of Jamaica and Electricity production(% of total) of Sudan?
Your answer should be very brief. -33.04. In the year 2003, what is the difference between the Electricity production(% of total) in Jamaica and Electricity production(% of total) in Venezuela?
Your answer should be compact. -64.31. In the year 2003, what is the difference between the Electricity production(% of total) of Sudan and Electricity production(% of total) of Venezuela?
Provide a short and direct response. -31.27. In the year 2004, what is the difference between the Electricity production(% of total) in North America and Electricity production(% of total) in Jamaica?
Your response must be concise. 11.03. In the year 2004, what is the difference between the Electricity production(% of total) in North America and Electricity production(% of total) in Sudan?
Provide a short and direct response. -19.05. In the year 2004, what is the difference between the Electricity production(% of total) of North America and Electricity production(% of total) of Venezuela?
Your answer should be compact. -58.22. In the year 2004, what is the difference between the Electricity production(% of total) of Jamaica and Electricity production(% of total) of Sudan?
Your answer should be very brief. -30.07. In the year 2004, what is the difference between the Electricity production(% of total) in Jamaica and Electricity production(% of total) in Venezuela?
Provide a short and direct response. -69.25. In the year 2004, what is the difference between the Electricity production(% of total) in Sudan and Electricity production(% of total) in Venezuela?
Ensure brevity in your answer.  -39.17. What is the ratio of the Electricity production(% of total) in North America in 1997 to that in 1998?
Your response must be concise. 1.12. What is the ratio of the Electricity production(% of total) of Jamaica in 1997 to that in 1998?
Ensure brevity in your answer.  1. What is the ratio of the Electricity production(% of total) in Sudan in 1997 to that in 1998?
Give a very brief answer. 0.92. What is the ratio of the Electricity production(% of total) in Venezuela in 1997 to that in 1998?
Provide a short and direct response. 1.02. What is the ratio of the Electricity production(% of total) of North America in 1997 to that in 1999?
Your answer should be compact. 1.15. What is the ratio of the Electricity production(% of total) of Jamaica in 1997 to that in 1999?
Your answer should be very brief. 1. What is the ratio of the Electricity production(% of total) in Sudan in 1997 to that in 1999?
Provide a short and direct response. 0.98. What is the ratio of the Electricity production(% of total) in Venezuela in 1997 to that in 1999?
Provide a succinct answer. 0.98. What is the ratio of the Electricity production(% of total) in North America in 1997 to that in 2000?
Provide a short and direct response. 1.22. What is the ratio of the Electricity production(% of total) of Jamaica in 1997 to that in 2000?
Your answer should be compact. 1.01. What is the ratio of the Electricity production(% of total) of Sudan in 1997 to that in 2000?
Provide a short and direct response. 1.06. What is the ratio of the Electricity production(% of total) in Venezuela in 1997 to that in 2000?
Make the answer very short. 0.99. What is the ratio of the Electricity production(% of total) of North America in 1997 to that in 2001?
Your answer should be very brief. 1.37. What is the ratio of the Electricity production(% of total) in Jamaica in 1997 to that in 2001?
Make the answer very short. 1.95. What is the ratio of the Electricity production(% of total) in Sudan in 1997 to that in 2001?
Give a very brief answer. 1.1. What is the ratio of the Electricity production(% of total) of Venezuela in 1997 to that in 2001?
Provide a succinct answer. 1.09. What is the ratio of the Electricity production(% of total) in North America in 1997 to that in 2002?
Make the answer very short. 1.21. What is the ratio of the Electricity production(% of total) of Jamaica in 1997 to that in 2002?
Provide a short and direct response. 1.3. What is the ratio of the Electricity production(% of total) in Sudan in 1997 to that in 2002?
Ensure brevity in your answer.  1.18. What is the ratio of the Electricity production(% of total) in Venezuela in 1997 to that in 2002?
Offer a very short reply. 1.13. What is the ratio of the Electricity production(% of total) in North America in 1997 to that in 2003?
Your answer should be very brief. 1.21. What is the ratio of the Electricity production(% of total) of Jamaica in 1997 to that in 2003?
Offer a terse response. 1.07. What is the ratio of the Electricity production(% of total) of Sudan in 1997 to that in 2003?
Give a very brief answer. 1.41. What is the ratio of the Electricity production(% of total) in Venezuela in 1997 to that in 2003?
Your response must be concise. 1.11. What is the ratio of the Electricity production(% of total) in North America in 1997 to that in 2004?
Provide a short and direct response. 1.25. What is the ratio of the Electricity production(% of total) in Jamaica in 1997 to that in 2004?
Offer a very short reply. 0.95. What is the ratio of the Electricity production(% of total) of Sudan in 1997 to that in 2004?
Your answer should be very brief. 1.54. What is the ratio of the Electricity production(% of total) of Venezuela in 1997 to that in 2004?
Keep it short and to the point. 1.03. What is the ratio of the Electricity production(% of total) in North America in 1998 to that in 1999?
Give a very brief answer. 1.03. What is the ratio of the Electricity production(% of total) of Sudan in 1998 to that in 1999?
Your answer should be compact. 1.06. What is the ratio of the Electricity production(% of total) of Venezuela in 1998 to that in 1999?
Provide a short and direct response. 0.95. What is the ratio of the Electricity production(% of total) in North America in 1998 to that in 2000?
Ensure brevity in your answer.  1.09. What is the ratio of the Electricity production(% of total) in Jamaica in 1998 to that in 2000?
Your answer should be very brief. 1.01. What is the ratio of the Electricity production(% of total) in Sudan in 1998 to that in 2000?
Ensure brevity in your answer.  1.15. What is the ratio of the Electricity production(% of total) in Venezuela in 1998 to that in 2000?
Give a very brief answer. 0.97. What is the ratio of the Electricity production(% of total) in North America in 1998 to that in 2001?
Provide a short and direct response. 1.22. What is the ratio of the Electricity production(% of total) of Jamaica in 1998 to that in 2001?
Provide a short and direct response. 1.95. What is the ratio of the Electricity production(% of total) in Sudan in 1998 to that in 2001?
Provide a succinct answer. 1.19. What is the ratio of the Electricity production(% of total) of Venezuela in 1998 to that in 2001?
Your response must be concise. 1.07. What is the ratio of the Electricity production(% of total) in North America in 1998 to that in 2002?
Provide a short and direct response. 1.08. What is the ratio of the Electricity production(% of total) in Jamaica in 1998 to that in 2002?
Offer a terse response. 1.3. What is the ratio of the Electricity production(% of total) of Sudan in 1998 to that in 2002?
Ensure brevity in your answer.  1.27. What is the ratio of the Electricity production(% of total) in Venezuela in 1998 to that in 2002?
Provide a succinct answer. 1.1. What is the ratio of the Electricity production(% of total) in North America in 1998 to that in 2003?
Keep it short and to the point. 1.08. What is the ratio of the Electricity production(% of total) of Jamaica in 1998 to that in 2003?
Give a very brief answer. 1.07. What is the ratio of the Electricity production(% of total) of Sudan in 1998 to that in 2003?
Offer a terse response. 1.53. What is the ratio of the Electricity production(% of total) in Venezuela in 1998 to that in 2003?
Your answer should be compact. 1.09. What is the ratio of the Electricity production(% of total) in North America in 1998 to that in 2004?
Give a very brief answer. 1.12. What is the ratio of the Electricity production(% of total) of Jamaica in 1998 to that in 2004?
Your answer should be compact. 0.95. What is the ratio of the Electricity production(% of total) in Sudan in 1998 to that in 2004?
Provide a succinct answer. 1.66. What is the ratio of the Electricity production(% of total) of Venezuela in 1998 to that in 2004?
Give a very brief answer. 1.01. What is the ratio of the Electricity production(% of total) of North America in 1999 to that in 2000?
Make the answer very short. 1.06. What is the ratio of the Electricity production(% of total) in Jamaica in 1999 to that in 2000?
Ensure brevity in your answer.  1.01. What is the ratio of the Electricity production(% of total) in Sudan in 1999 to that in 2000?
Offer a very short reply. 1.08. What is the ratio of the Electricity production(% of total) of Venezuela in 1999 to that in 2000?
Your answer should be very brief. 1.02. What is the ratio of the Electricity production(% of total) in North America in 1999 to that in 2001?
Make the answer very short. 1.19. What is the ratio of the Electricity production(% of total) of Jamaica in 1999 to that in 2001?
Offer a very short reply. 1.95. What is the ratio of the Electricity production(% of total) of Sudan in 1999 to that in 2001?
Ensure brevity in your answer.  1.12. What is the ratio of the Electricity production(% of total) in Venezuela in 1999 to that in 2001?
Provide a short and direct response. 1.12. What is the ratio of the Electricity production(% of total) in North America in 1999 to that in 2002?
Offer a very short reply. 1.05. What is the ratio of the Electricity production(% of total) of Jamaica in 1999 to that in 2002?
Your response must be concise. 1.29. What is the ratio of the Electricity production(% of total) in Sudan in 1999 to that in 2002?
Give a very brief answer. 1.2. What is the ratio of the Electricity production(% of total) of Venezuela in 1999 to that in 2002?
Ensure brevity in your answer.  1.16. What is the ratio of the Electricity production(% of total) of North America in 1999 to that in 2003?
Give a very brief answer. 1.06. What is the ratio of the Electricity production(% of total) in Jamaica in 1999 to that in 2003?
Keep it short and to the point. 1.07. What is the ratio of the Electricity production(% of total) of Sudan in 1999 to that in 2003?
Make the answer very short. 1.44. What is the ratio of the Electricity production(% of total) of Venezuela in 1999 to that in 2003?
Give a very brief answer. 1.14. What is the ratio of the Electricity production(% of total) in North America in 1999 to that in 2004?
Keep it short and to the point. 1.09. What is the ratio of the Electricity production(% of total) of Jamaica in 1999 to that in 2004?
Offer a very short reply. 0.95. What is the ratio of the Electricity production(% of total) of Sudan in 1999 to that in 2004?
Make the answer very short. 1.56. What is the ratio of the Electricity production(% of total) of Venezuela in 1999 to that in 2004?
Offer a terse response. 1.06. What is the ratio of the Electricity production(% of total) in North America in 2000 to that in 2001?
Keep it short and to the point. 1.12. What is the ratio of the Electricity production(% of total) of Jamaica in 2000 to that in 2001?
Offer a terse response. 1.93. What is the ratio of the Electricity production(% of total) in Sudan in 2000 to that in 2001?
Give a very brief answer. 1.03. What is the ratio of the Electricity production(% of total) of Venezuela in 2000 to that in 2001?
Offer a terse response. 1.1. What is the ratio of the Electricity production(% of total) in Jamaica in 2000 to that in 2002?
Your answer should be very brief. 1.28. What is the ratio of the Electricity production(% of total) of Sudan in 2000 to that in 2002?
Your response must be concise. 1.11. What is the ratio of the Electricity production(% of total) in Venezuela in 2000 to that in 2002?
Offer a very short reply. 1.14. What is the ratio of the Electricity production(% of total) in North America in 2000 to that in 2003?
Keep it short and to the point. 1. What is the ratio of the Electricity production(% of total) in Jamaica in 2000 to that in 2003?
Provide a short and direct response. 1.06. What is the ratio of the Electricity production(% of total) of Sudan in 2000 to that in 2003?
Ensure brevity in your answer.  1.33. What is the ratio of the Electricity production(% of total) of Venezuela in 2000 to that in 2003?
Make the answer very short. 1.12. What is the ratio of the Electricity production(% of total) in North America in 2000 to that in 2004?
Give a very brief answer. 1.02. What is the ratio of the Electricity production(% of total) in Jamaica in 2000 to that in 2004?
Keep it short and to the point. 0.94. What is the ratio of the Electricity production(% of total) of Sudan in 2000 to that in 2004?
Offer a very short reply. 1.44. What is the ratio of the Electricity production(% of total) in Venezuela in 2000 to that in 2004?
Offer a very short reply. 1.04. What is the ratio of the Electricity production(% of total) in North America in 2001 to that in 2002?
Your response must be concise. 0.88. What is the ratio of the Electricity production(% of total) in Jamaica in 2001 to that in 2002?
Your response must be concise. 0.67. What is the ratio of the Electricity production(% of total) of Sudan in 2001 to that in 2002?
Offer a terse response. 1.07. What is the ratio of the Electricity production(% of total) of Venezuela in 2001 to that in 2002?
Provide a succinct answer. 1.03. What is the ratio of the Electricity production(% of total) in North America in 2001 to that in 2003?
Your answer should be very brief. 0.89. What is the ratio of the Electricity production(% of total) in Jamaica in 2001 to that in 2003?
Make the answer very short. 0.55. What is the ratio of the Electricity production(% of total) in Sudan in 2001 to that in 2003?
Offer a very short reply. 1.29. What is the ratio of the Electricity production(% of total) in Venezuela in 2001 to that in 2003?
Your response must be concise. 1.02. What is the ratio of the Electricity production(% of total) of North America in 2001 to that in 2004?
Offer a terse response. 0.91. What is the ratio of the Electricity production(% of total) of Jamaica in 2001 to that in 2004?
Your answer should be very brief. 0.49. What is the ratio of the Electricity production(% of total) in Sudan in 2001 to that in 2004?
Your response must be concise. 1.4. What is the ratio of the Electricity production(% of total) in Venezuela in 2001 to that in 2004?
Make the answer very short. 0.94. What is the ratio of the Electricity production(% of total) in Jamaica in 2002 to that in 2003?
Provide a succinct answer. 0.83. What is the ratio of the Electricity production(% of total) in Venezuela in 2002 to that in 2003?
Keep it short and to the point. 0.98. What is the ratio of the Electricity production(% of total) in North America in 2002 to that in 2004?
Provide a succinct answer. 1.04. What is the ratio of the Electricity production(% of total) in Jamaica in 2002 to that in 2004?
Offer a terse response. 0.73. What is the ratio of the Electricity production(% of total) of Sudan in 2002 to that in 2004?
Provide a succinct answer. 1.3. What is the ratio of the Electricity production(% of total) in Venezuela in 2002 to that in 2004?
Your answer should be compact. 0.91. What is the ratio of the Electricity production(% of total) of North America in 2003 to that in 2004?
Your answer should be compact. 1.03. What is the ratio of the Electricity production(% of total) in Jamaica in 2003 to that in 2004?
Provide a short and direct response. 0.88. What is the ratio of the Electricity production(% of total) in Sudan in 2003 to that in 2004?
Your response must be concise. 1.09. What is the ratio of the Electricity production(% of total) of Venezuela in 2003 to that in 2004?
Give a very brief answer. 0.93. What is the difference between the highest and the second highest Electricity production(% of total) of North America?
Your answer should be compact. 1.72. What is the difference between the highest and the second highest Electricity production(% of total) in Jamaica?
Provide a short and direct response. 0.1. What is the difference between the highest and the second highest Electricity production(% of total) in Sudan?
Provide a succinct answer. 3.11. What is the difference between the highest and the second highest Electricity production(% of total) in Venezuela?
Make the answer very short. 1.42. What is the difference between the highest and the lowest Electricity production(% of total) of North America?
Make the answer very short. 4.33. What is the difference between the highest and the lowest Electricity production(% of total) of Jamaica?
Provide a succinct answer. 0.96. What is the difference between the highest and the lowest Electricity production(% of total) of Sudan?
Provide a succinct answer. 21.12. What is the difference between the highest and the lowest Electricity production(% of total) of Venezuela?
Keep it short and to the point. 10.35. 